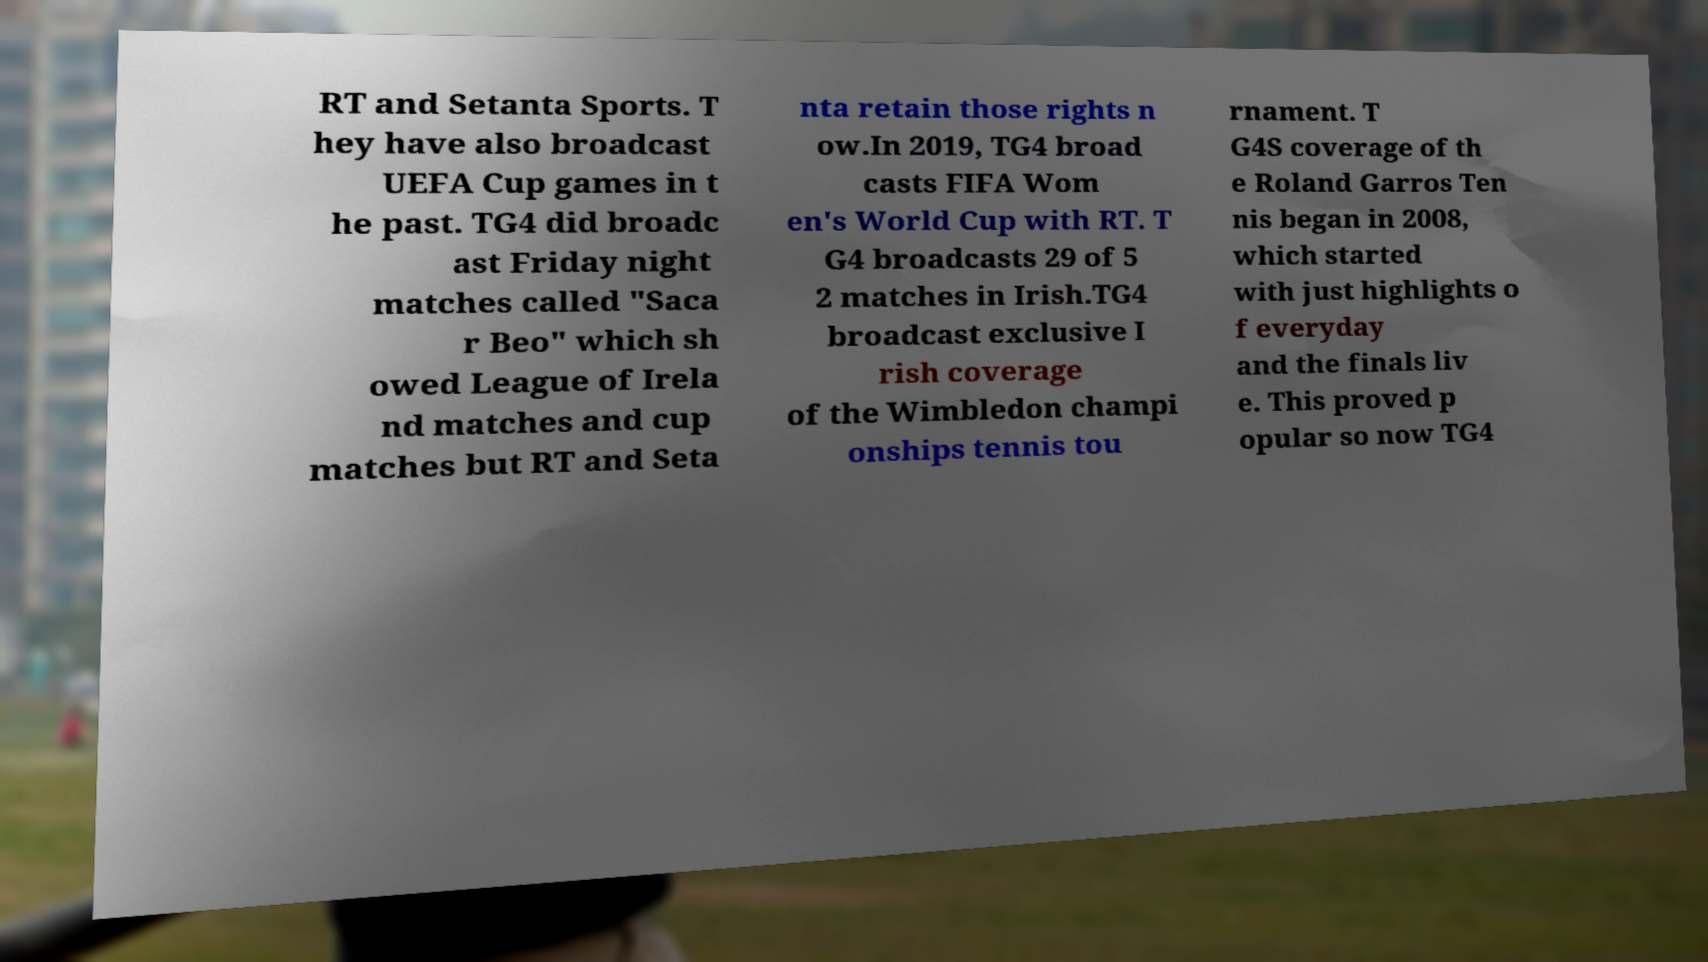Could you assist in decoding the text presented in this image and type it out clearly? RT and Setanta Sports. T hey have also broadcast UEFA Cup games in t he past. TG4 did broadc ast Friday night matches called "Saca r Beo" which sh owed League of Irela nd matches and cup matches but RT and Seta nta retain those rights n ow.In 2019, TG4 broad casts FIFA Wom en's World Cup with RT. T G4 broadcasts 29 of 5 2 matches in Irish.TG4 broadcast exclusive I rish coverage of the Wimbledon champi onships tennis tou rnament. T G4S coverage of th e Roland Garros Ten nis began in 2008, which started with just highlights o f everyday and the finals liv e. This proved p opular so now TG4 